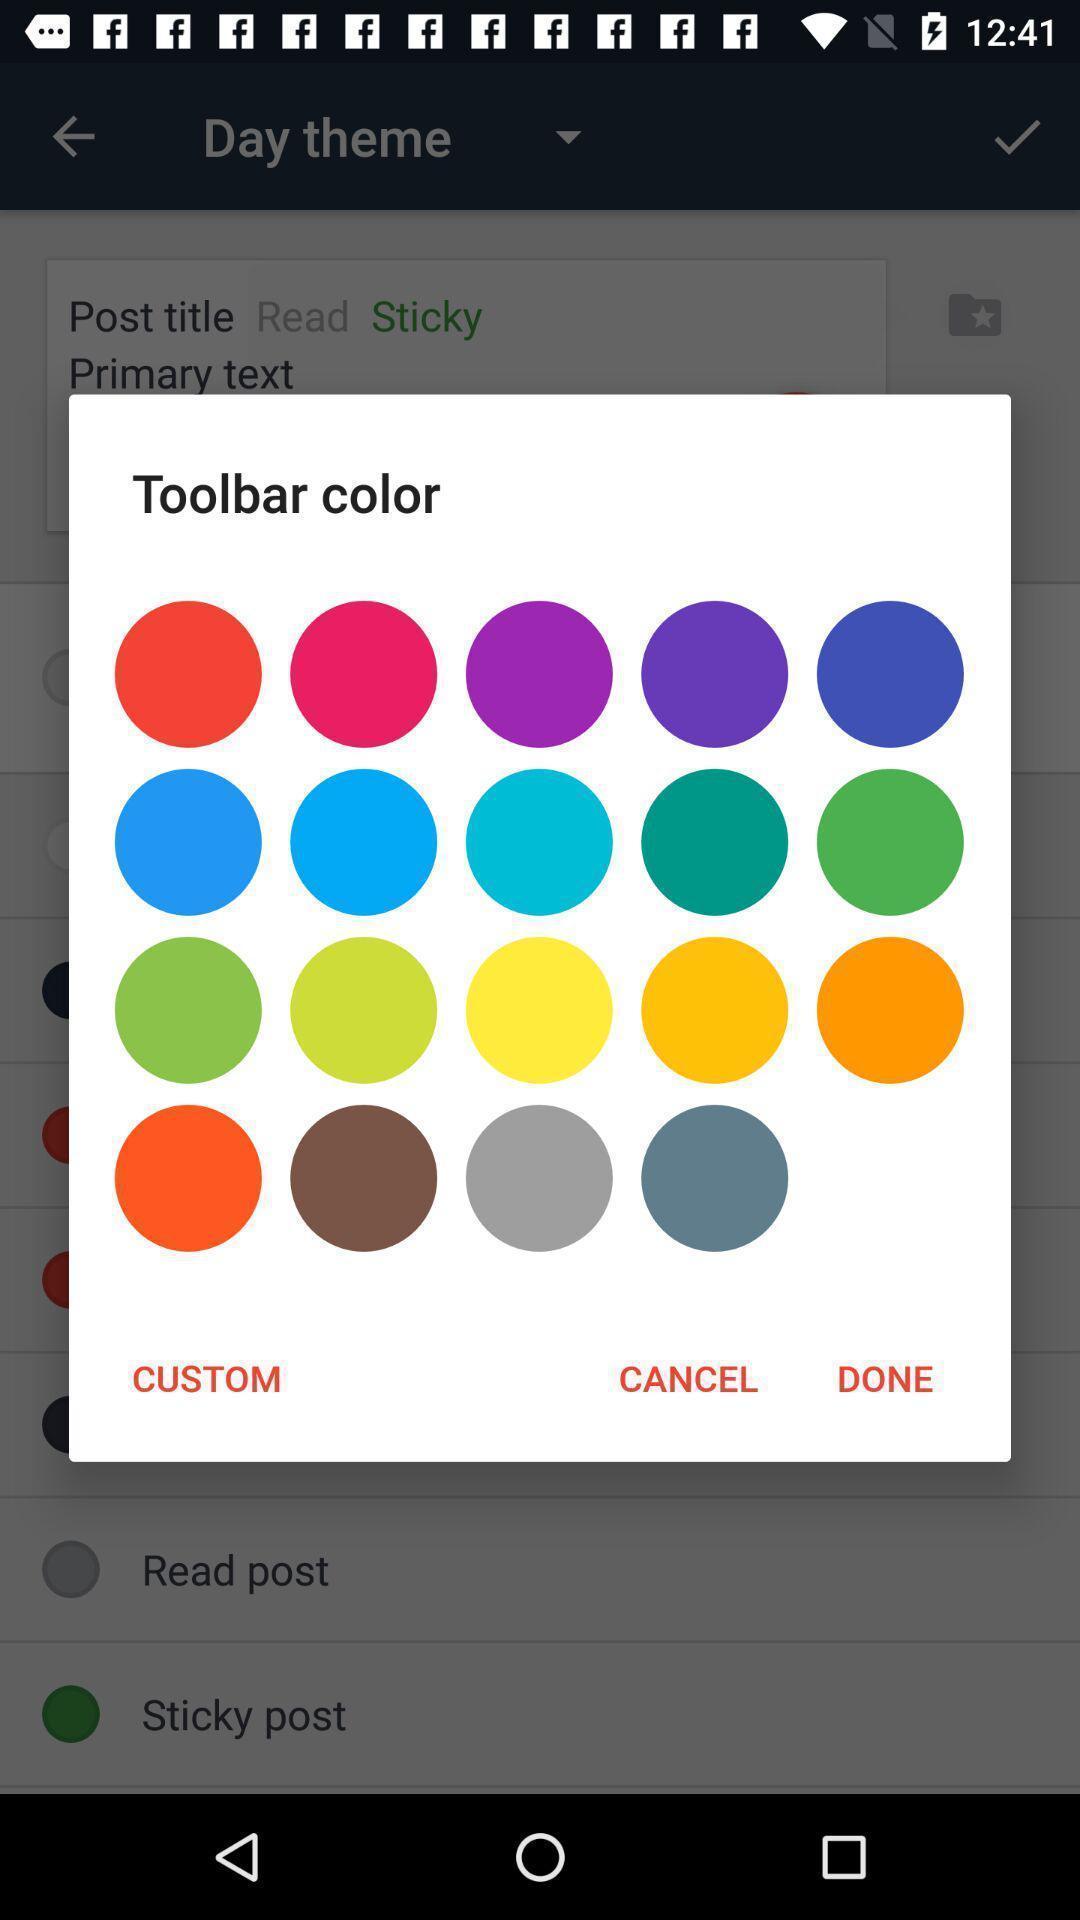Provide a description of this screenshot. Popup showing about different colors. 